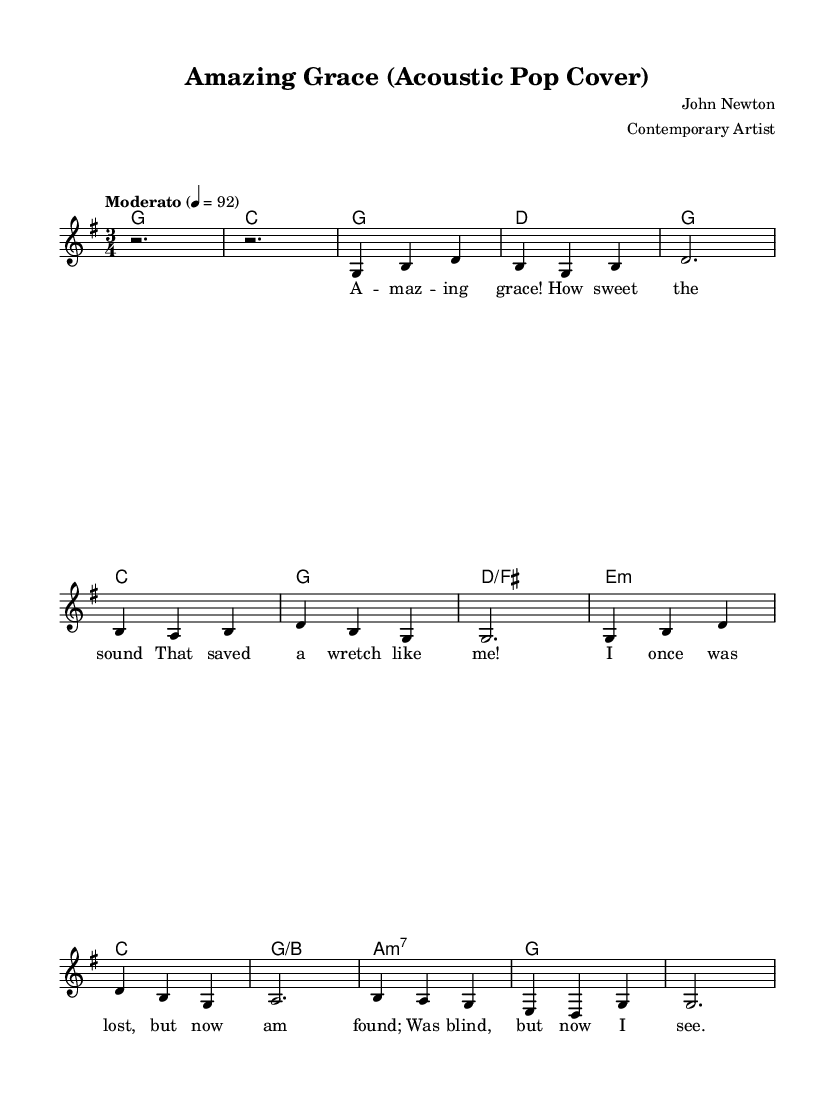What is the key signature of this music? The key signature is G major, which has one sharp (F#).
Answer: G major What is the time signature of this music? The time signature is three-four, indicating three beats per measure.
Answer: Three-four What is the tempo marking for this piece? The tempo marking indicates "Moderato," which suggests a moderate pace of speed.
Answer: Moderato How many measures are in the first verse? The first verse consists of six measures as indicated by the grouping of notes and rests.
Answer: Six measures Which artist arranged this cover of "Amazing Grace"? The arranger credited is a "Contemporary Artist," though their specific name is not given.
Answer: Contemporary Artist What is the chord progression for the chorus? The chord progression for the chorus is G, C, G, D, G, C, G, D/F#, E minor, C, G/B, A minor 7, G. This shows a common structure of alternating between major and minor chords.
Answer: G C G D G C G D/F# E minor C G/B A minor 7 G How does the instrumentation reflect the pop style in this hymn arrangement? The arrangement uses a single staff for vocal melody complemented by chord symbols, which is characteristic of pop music arrangements that focus on accessible performance.
Answer: Single staff with chord symbols 